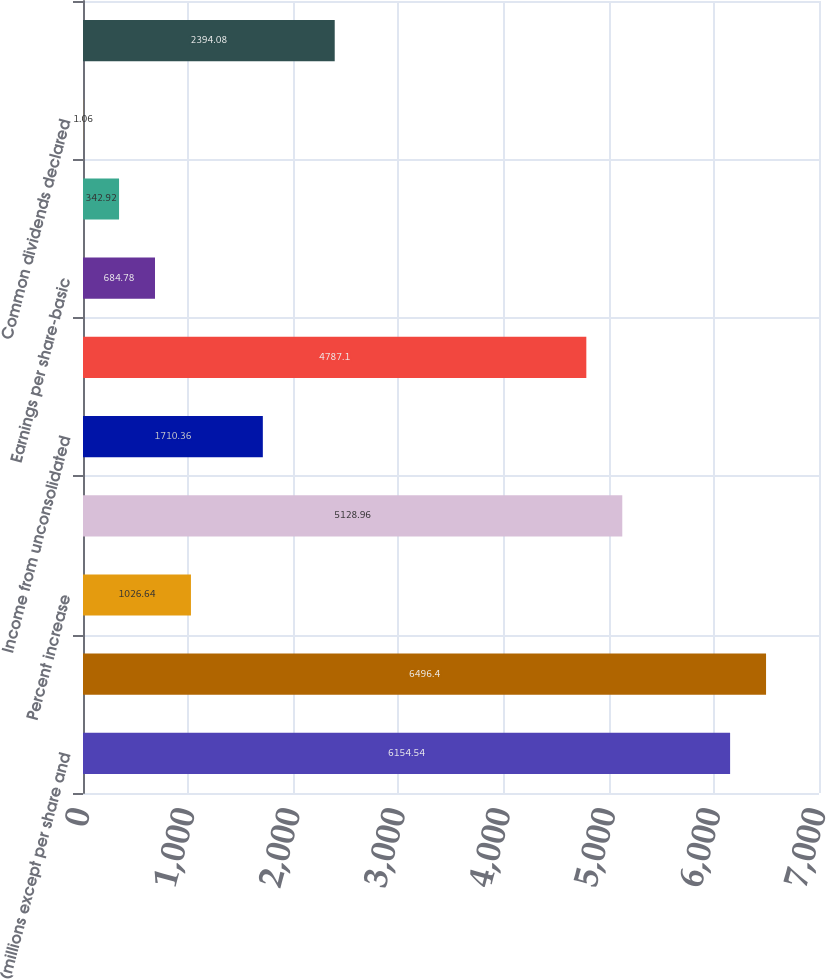Convert chart to OTSL. <chart><loc_0><loc_0><loc_500><loc_500><bar_chart><fcel>(millions except per share and<fcel>Net sales<fcel>Percent increase<fcel>Operating income<fcel>Income from unconsolidated<fcel>Net income<fcel>Earnings per share-basic<fcel>Earnings per share-diluted<fcel>Common dividends declared<fcel>Closing price non-voting<nl><fcel>6154.54<fcel>6496.4<fcel>1026.64<fcel>5128.96<fcel>1710.36<fcel>4787.1<fcel>684.78<fcel>342.92<fcel>1.06<fcel>2394.08<nl></chart> 